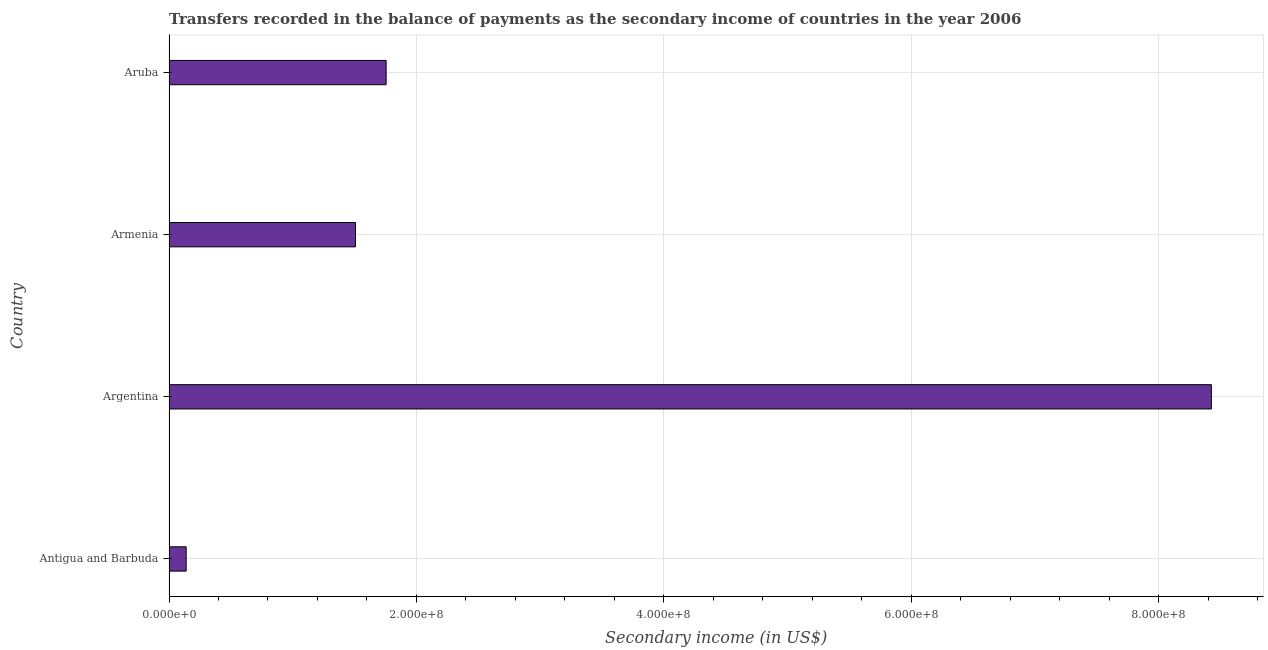Does the graph contain any zero values?
Offer a terse response. No. What is the title of the graph?
Ensure brevity in your answer.  Transfers recorded in the balance of payments as the secondary income of countries in the year 2006. What is the label or title of the X-axis?
Ensure brevity in your answer.  Secondary income (in US$). What is the label or title of the Y-axis?
Offer a very short reply. Country. What is the amount of secondary income in Aruba?
Your response must be concise. 1.76e+08. Across all countries, what is the maximum amount of secondary income?
Make the answer very short. 8.43e+08. Across all countries, what is the minimum amount of secondary income?
Give a very brief answer. 1.39e+07. In which country was the amount of secondary income minimum?
Offer a terse response. Antigua and Barbuda. What is the sum of the amount of secondary income?
Your answer should be very brief. 1.18e+09. What is the difference between the amount of secondary income in Antigua and Barbuda and Argentina?
Ensure brevity in your answer.  -8.29e+08. What is the average amount of secondary income per country?
Ensure brevity in your answer.  2.96e+08. What is the median amount of secondary income?
Offer a terse response. 1.63e+08. In how many countries, is the amount of secondary income greater than 200000000 US$?
Give a very brief answer. 1. What is the ratio of the amount of secondary income in Antigua and Barbuda to that in Aruba?
Ensure brevity in your answer.  0.08. What is the difference between the highest and the second highest amount of secondary income?
Your answer should be compact. 6.67e+08. What is the difference between the highest and the lowest amount of secondary income?
Give a very brief answer. 8.29e+08. In how many countries, is the amount of secondary income greater than the average amount of secondary income taken over all countries?
Your answer should be compact. 1. How many bars are there?
Provide a short and direct response. 4. Are all the bars in the graph horizontal?
Provide a succinct answer. Yes. What is the Secondary income (in US$) in Antigua and Barbuda?
Ensure brevity in your answer.  1.39e+07. What is the Secondary income (in US$) in Argentina?
Provide a succinct answer. 8.43e+08. What is the Secondary income (in US$) of Armenia?
Provide a short and direct response. 1.51e+08. What is the Secondary income (in US$) of Aruba?
Make the answer very short. 1.76e+08. What is the difference between the Secondary income (in US$) in Antigua and Barbuda and Argentina?
Provide a short and direct response. -8.29e+08. What is the difference between the Secondary income (in US$) in Antigua and Barbuda and Armenia?
Provide a short and direct response. -1.37e+08. What is the difference between the Secondary income (in US$) in Antigua and Barbuda and Aruba?
Your answer should be very brief. -1.62e+08. What is the difference between the Secondary income (in US$) in Argentina and Armenia?
Provide a succinct answer. 6.92e+08. What is the difference between the Secondary income (in US$) in Argentina and Aruba?
Give a very brief answer. 6.67e+08. What is the difference between the Secondary income (in US$) in Armenia and Aruba?
Provide a succinct answer. -2.47e+07. What is the ratio of the Secondary income (in US$) in Antigua and Barbuda to that in Argentina?
Your answer should be compact. 0.02. What is the ratio of the Secondary income (in US$) in Antigua and Barbuda to that in Armenia?
Keep it short and to the point. 0.09. What is the ratio of the Secondary income (in US$) in Antigua and Barbuda to that in Aruba?
Provide a short and direct response. 0.08. What is the ratio of the Secondary income (in US$) in Argentina to that in Armenia?
Your answer should be very brief. 5.59. What is the ratio of the Secondary income (in US$) in Argentina to that in Aruba?
Provide a short and direct response. 4.8. What is the ratio of the Secondary income (in US$) in Armenia to that in Aruba?
Offer a very short reply. 0.86. 